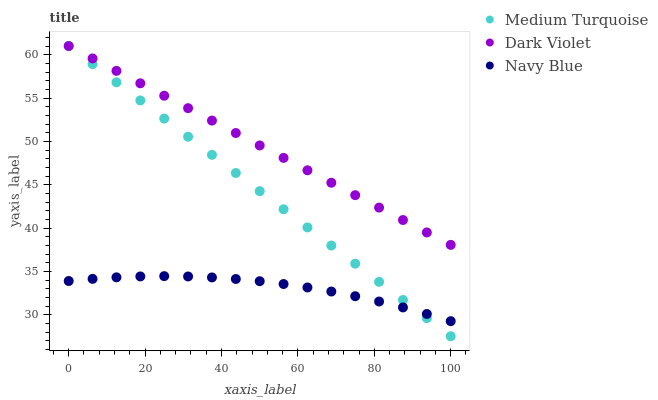Does Navy Blue have the minimum area under the curve?
Answer yes or no. Yes. Does Dark Violet have the maximum area under the curve?
Answer yes or no. Yes. Does Medium Turquoise have the minimum area under the curve?
Answer yes or no. No. Does Medium Turquoise have the maximum area under the curve?
Answer yes or no. No. Is Medium Turquoise the smoothest?
Answer yes or no. Yes. Is Navy Blue the roughest?
Answer yes or no. Yes. Is Dark Violet the smoothest?
Answer yes or no. No. Is Dark Violet the roughest?
Answer yes or no. No. Does Medium Turquoise have the lowest value?
Answer yes or no. Yes. Does Dark Violet have the lowest value?
Answer yes or no. No. Does Medium Turquoise have the highest value?
Answer yes or no. Yes. Is Navy Blue less than Dark Violet?
Answer yes or no. Yes. Is Dark Violet greater than Navy Blue?
Answer yes or no. Yes. Does Dark Violet intersect Medium Turquoise?
Answer yes or no. Yes. Is Dark Violet less than Medium Turquoise?
Answer yes or no. No. Is Dark Violet greater than Medium Turquoise?
Answer yes or no. No. Does Navy Blue intersect Dark Violet?
Answer yes or no. No. 